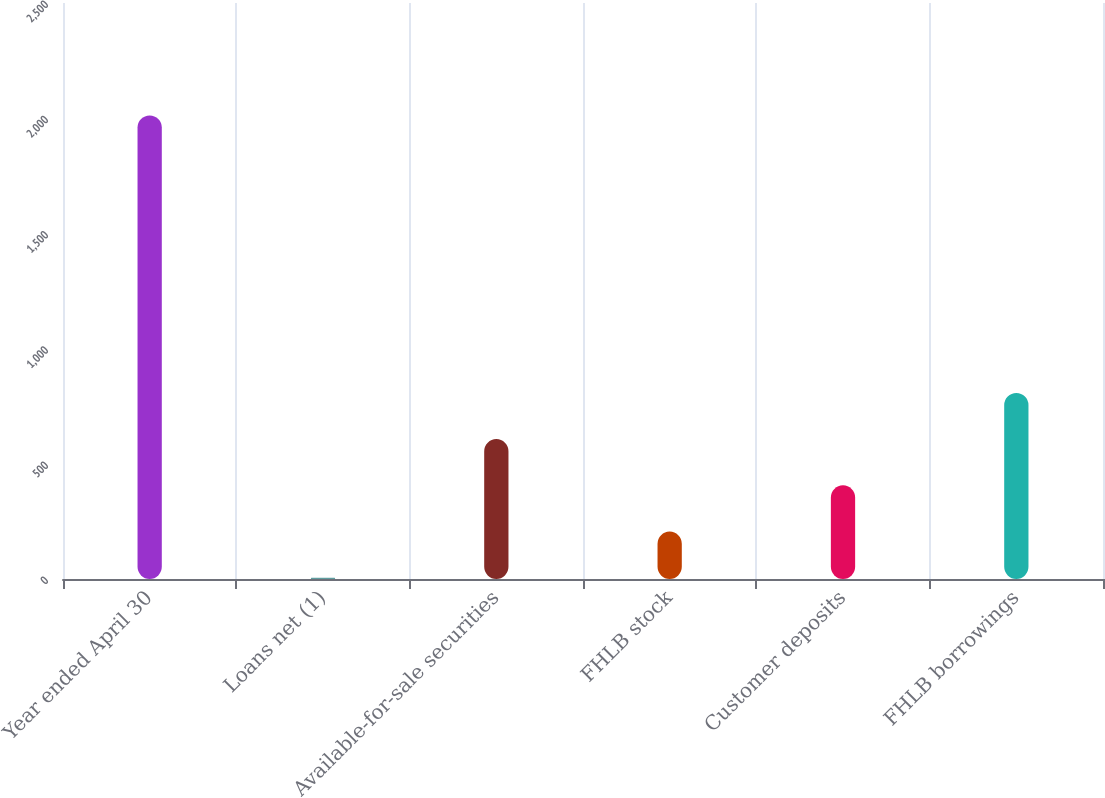Convert chart to OTSL. <chart><loc_0><loc_0><loc_500><loc_500><bar_chart><fcel>Year ended April 30<fcel>Loans net (1)<fcel>Available-for-sale securities<fcel>FHLB stock<fcel>Customer deposits<fcel>FHLB borrowings<nl><fcel>2012<fcel>5<fcel>607.1<fcel>205.7<fcel>406.4<fcel>807.8<nl></chart> 